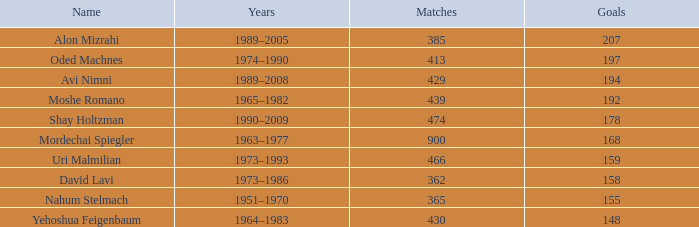What is the Rank of the player with 158 Goals in more than 362 Matches? 0.0. 